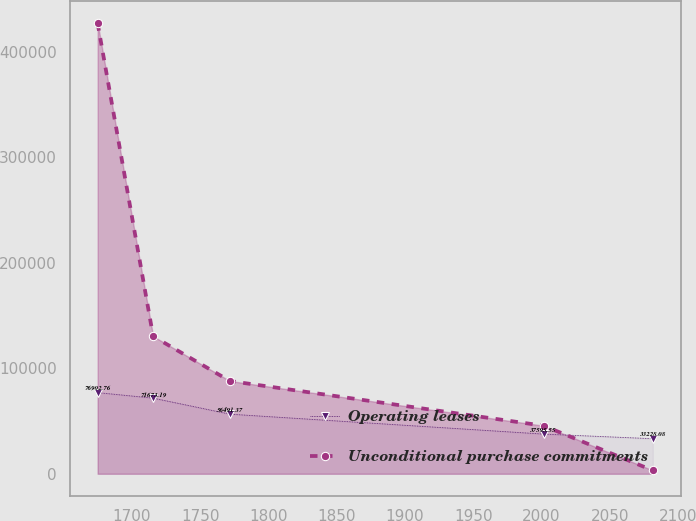<chart> <loc_0><loc_0><loc_500><loc_500><line_chart><ecel><fcel>Operating leases<fcel>Unconditional purchase commitments<nl><fcel>1674.8<fcel>76902.8<fcel>426959<nl><fcel>1715.47<fcel>71673.2<fcel>130309<nl><fcel>1771.71<fcel>56491.4<fcel>87930.7<nl><fcel>2001.5<fcel>37595.6<fcel>45552.2<nl><fcel>2081.52<fcel>33228.1<fcel>3173.76<nl></chart> 